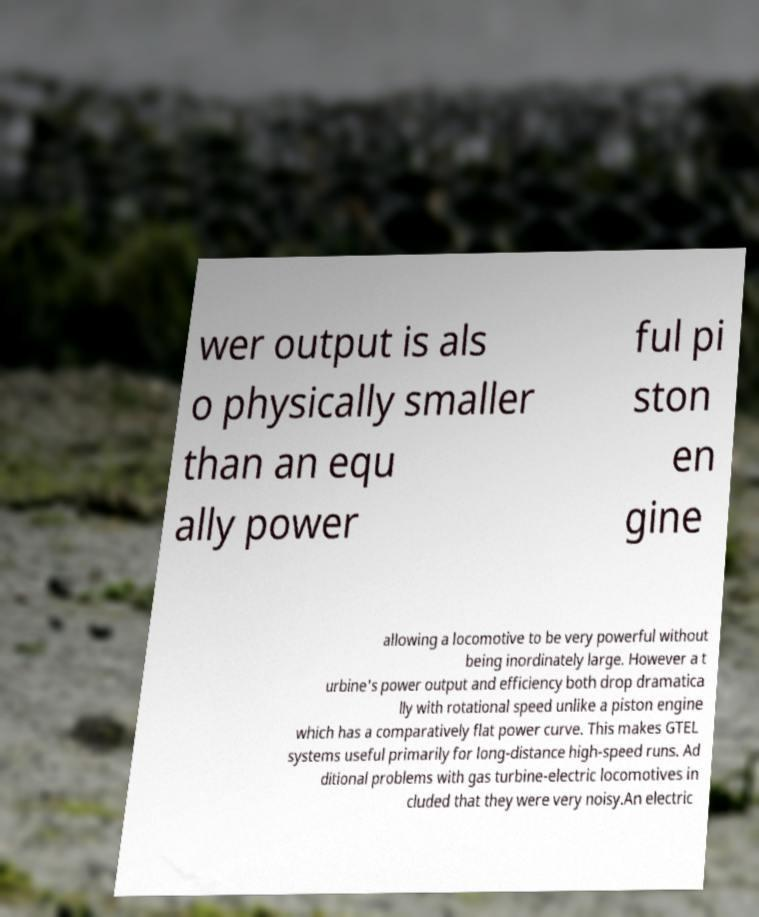Can you read and provide the text displayed in the image?This photo seems to have some interesting text. Can you extract and type it out for me? wer output is als o physically smaller than an equ ally power ful pi ston en gine allowing a locomotive to be very powerful without being inordinately large. However a t urbine's power output and efficiency both drop dramatica lly with rotational speed unlike a piston engine which has a comparatively flat power curve. This makes GTEL systems useful primarily for long-distance high-speed runs. Ad ditional problems with gas turbine-electric locomotives in cluded that they were very noisy.An electric 